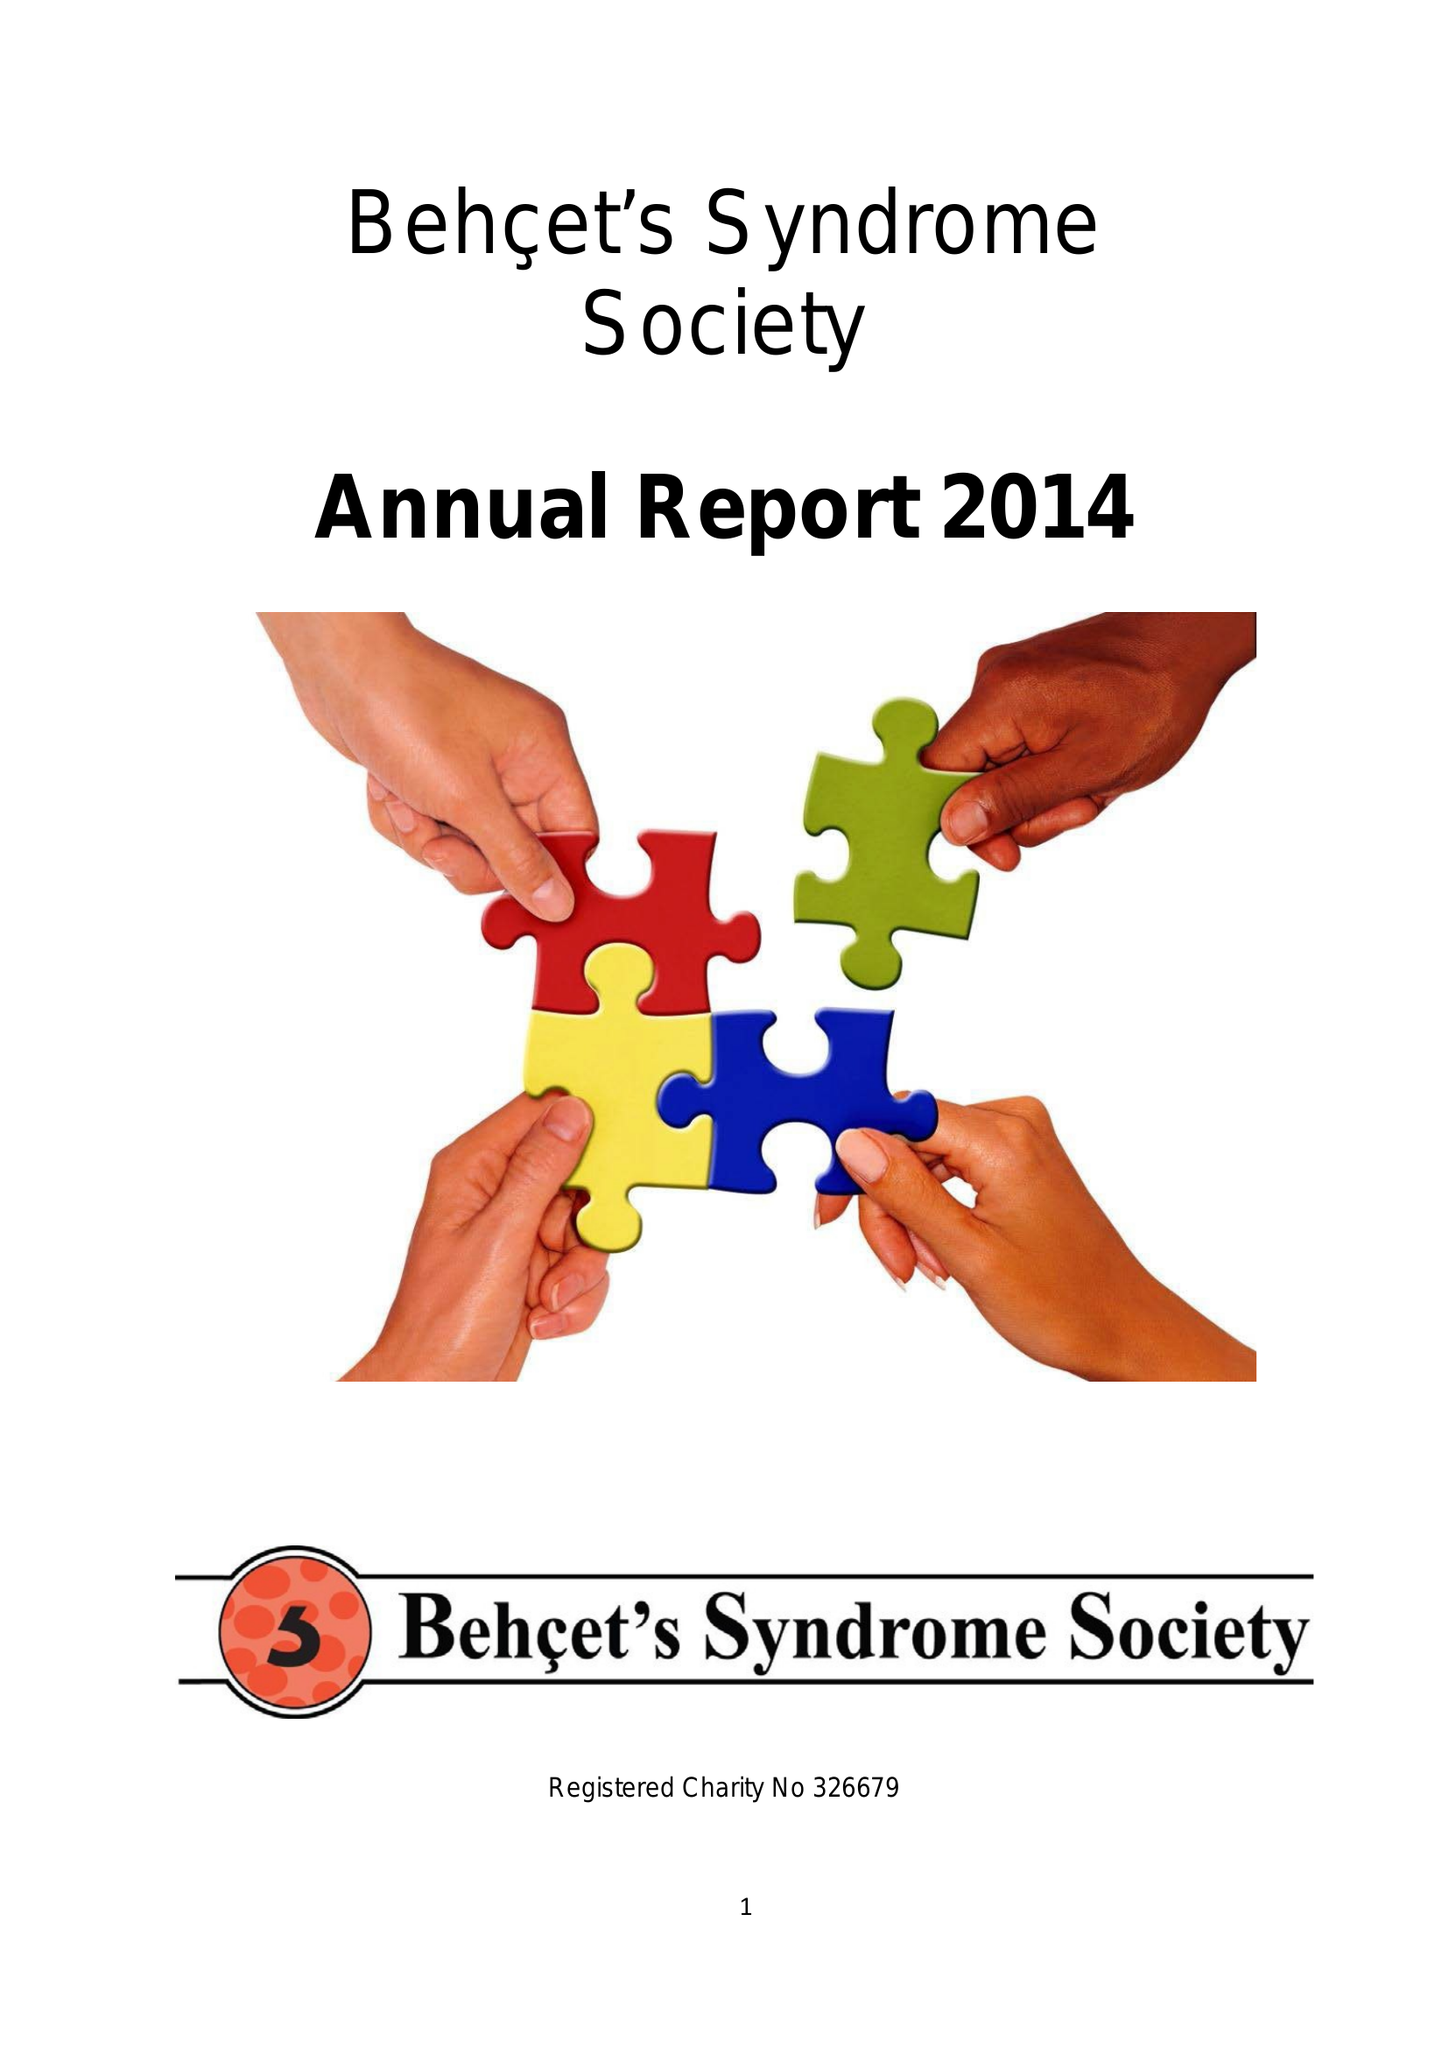What is the value for the report_date?
Answer the question using a single word or phrase. 2014-08-31 